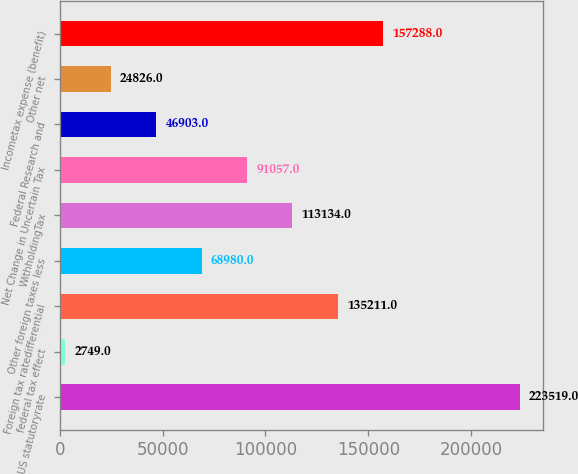Convert chart. <chart><loc_0><loc_0><loc_500><loc_500><bar_chart><fcel>US statutoryrate<fcel>federal tax effect<fcel>Foreign tax ratedifferential<fcel>Other foreign taxes less<fcel>WithholdingTax<fcel>Net Change in Uncertain Tax<fcel>Federal Research and<fcel>Other net<fcel>Incometax expense (benefit)<nl><fcel>223519<fcel>2749<fcel>135211<fcel>68980<fcel>113134<fcel>91057<fcel>46903<fcel>24826<fcel>157288<nl></chart> 